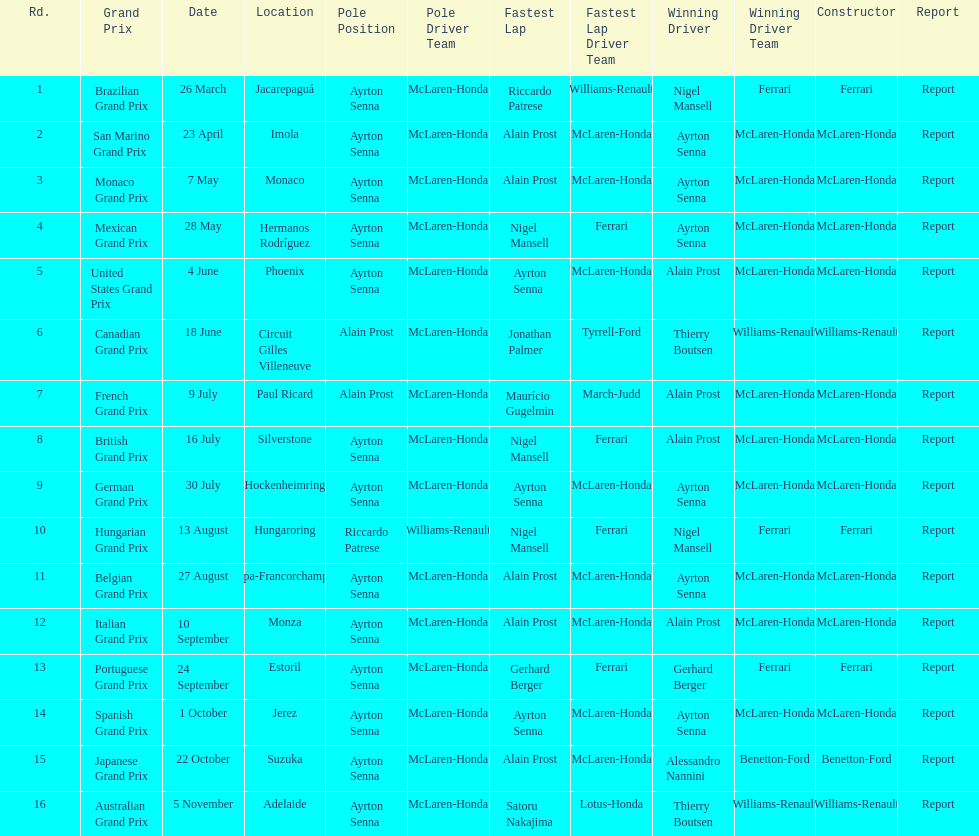What grand prix was before the san marino grand prix? Brazilian Grand Prix. 